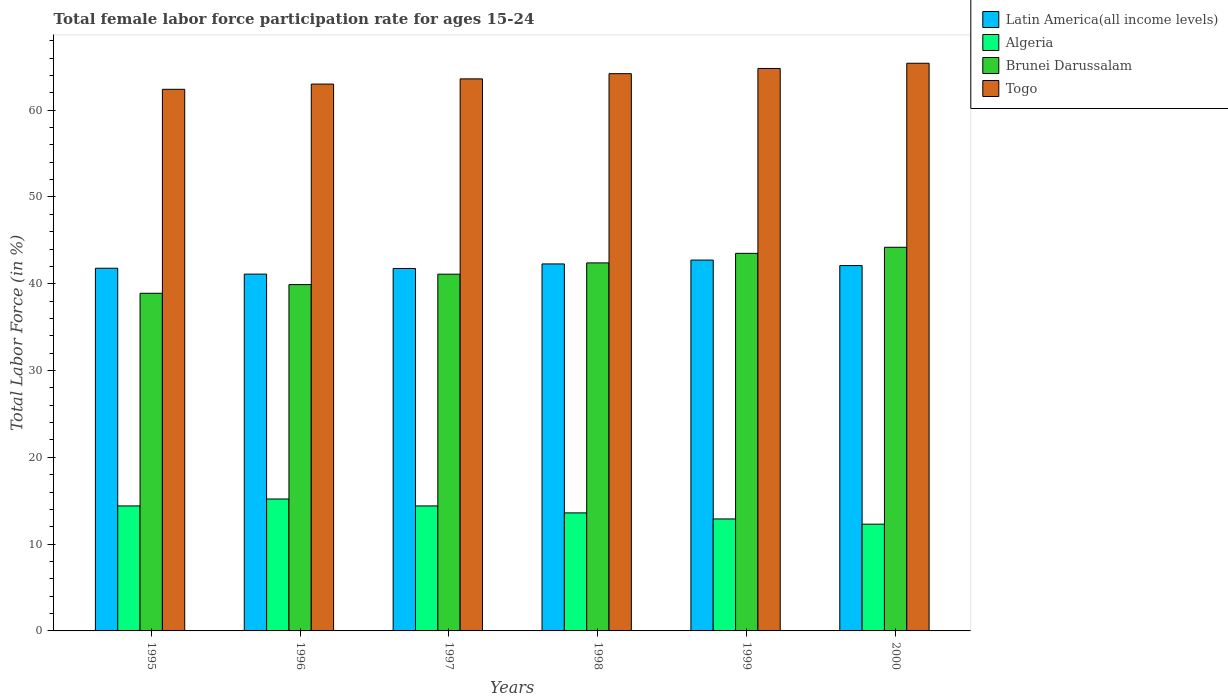How many different coloured bars are there?
Your answer should be very brief. 4. How many bars are there on the 4th tick from the right?
Your answer should be compact. 4. What is the label of the 3rd group of bars from the left?
Offer a terse response. 1997. What is the female labor force participation rate in Latin America(all income levels) in 1998?
Offer a very short reply. 42.28. Across all years, what is the maximum female labor force participation rate in Latin America(all income levels)?
Your answer should be compact. 42.72. Across all years, what is the minimum female labor force participation rate in Togo?
Your answer should be compact. 62.4. What is the total female labor force participation rate in Togo in the graph?
Your answer should be compact. 383.4. What is the difference between the female labor force participation rate in Brunei Darussalam in 1997 and that in 2000?
Ensure brevity in your answer.  -3.1. What is the difference between the female labor force participation rate in Latin America(all income levels) in 1998 and the female labor force participation rate in Brunei Darussalam in 1996?
Give a very brief answer. 2.38. What is the average female labor force participation rate in Algeria per year?
Offer a very short reply. 13.8. In the year 1999, what is the difference between the female labor force participation rate in Latin America(all income levels) and female labor force participation rate in Brunei Darussalam?
Your answer should be very brief. -0.78. In how many years, is the female labor force participation rate in Latin America(all income levels) greater than 10 %?
Your response must be concise. 6. What is the ratio of the female labor force participation rate in Latin America(all income levels) in 1996 to that in 1999?
Keep it short and to the point. 0.96. Is the female labor force participation rate in Algeria in 1996 less than that in 1997?
Provide a succinct answer. No. Is the difference between the female labor force participation rate in Latin America(all income levels) in 1999 and 2000 greater than the difference between the female labor force participation rate in Brunei Darussalam in 1999 and 2000?
Provide a short and direct response. Yes. What is the difference between the highest and the second highest female labor force participation rate in Algeria?
Provide a short and direct response. 0.8. What is the difference between the highest and the lowest female labor force participation rate in Togo?
Keep it short and to the point. 3. What does the 1st bar from the left in 1997 represents?
Keep it short and to the point. Latin America(all income levels). What does the 2nd bar from the right in 1997 represents?
Offer a very short reply. Brunei Darussalam. Is it the case that in every year, the sum of the female labor force participation rate in Algeria and female labor force participation rate in Brunei Darussalam is greater than the female labor force participation rate in Latin America(all income levels)?
Provide a succinct answer. Yes. How many bars are there?
Provide a succinct answer. 24. Are all the bars in the graph horizontal?
Your response must be concise. No. How many years are there in the graph?
Provide a short and direct response. 6. What is the difference between two consecutive major ticks on the Y-axis?
Ensure brevity in your answer.  10. How many legend labels are there?
Provide a succinct answer. 4. What is the title of the graph?
Your response must be concise. Total female labor force participation rate for ages 15-24. What is the label or title of the Y-axis?
Provide a short and direct response. Total Labor Force (in %). What is the Total Labor Force (in %) of Latin America(all income levels) in 1995?
Offer a very short reply. 41.78. What is the Total Labor Force (in %) of Algeria in 1995?
Your answer should be compact. 14.4. What is the Total Labor Force (in %) in Brunei Darussalam in 1995?
Your answer should be compact. 38.9. What is the Total Labor Force (in %) in Togo in 1995?
Your answer should be very brief. 62.4. What is the Total Labor Force (in %) of Latin America(all income levels) in 1996?
Keep it short and to the point. 41.11. What is the Total Labor Force (in %) in Algeria in 1996?
Offer a very short reply. 15.2. What is the Total Labor Force (in %) of Brunei Darussalam in 1996?
Offer a very short reply. 39.9. What is the Total Labor Force (in %) of Latin America(all income levels) in 1997?
Your response must be concise. 41.76. What is the Total Labor Force (in %) of Algeria in 1997?
Ensure brevity in your answer.  14.4. What is the Total Labor Force (in %) of Brunei Darussalam in 1997?
Your answer should be compact. 41.1. What is the Total Labor Force (in %) in Togo in 1997?
Keep it short and to the point. 63.6. What is the Total Labor Force (in %) of Latin America(all income levels) in 1998?
Provide a short and direct response. 42.28. What is the Total Labor Force (in %) in Algeria in 1998?
Offer a very short reply. 13.6. What is the Total Labor Force (in %) of Brunei Darussalam in 1998?
Your response must be concise. 42.4. What is the Total Labor Force (in %) of Togo in 1998?
Ensure brevity in your answer.  64.2. What is the Total Labor Force (in %) in Latin America(all income levels) in 1999?
Give a very brief answer. 42.72. What is the Total Labor Force (in %) of Algeria in 1999?
Ensure brevity in your answer.  12.9. What is the Total Labor Force (in %) of Brunei Darussalam in 1999?
Offer a terse response. 43.5. What is the Total Labor Force (in %) in Togo in 1999?
Give a very brief answer. 64.8. What is the Total Labor Force (in %) of Latin America(all income levels) in 2000?
Your answer should be very brief. 42.09. What is the Total Labor Force (in %) in Algeria in 2000?
Your response must be concise. 12.3. What is the Total Labor Force (in %) in Brunei Darussalam in 2000?
Your answer should be very brief. 44.2. What is the Total Labor Force (in %) in Togo in 2000?
Your answer should be very brief. 65.4. Across all years, what is the maximum Total Labor Force (in %) in Latin America(all income levels)?
Give a very brief answer. 42.72. Across all years, what is the maximum Total Labor Force (in %) of Algeria?
Offer a very short reply. 15.2. Across all years, what is the maximum Total Labor Force (in %) of Brunei Darussalam?
Offer a very short reply. 44.2. Across all years, what is the maximum Total Labor Force (in %) of Togo?
Your answer should be compact. 65.4. Across all years, what is the minimum Total Labor Force (in %) in Latin America(all income levels)?
Keep it short and to the point. 41.11. Across all years, what is the minimum Total Labor Force (in %) in Algeria?
Offer a very short reply. 12.3. Across all years, what is the minimum Total Labor Force (in %) of Brunei Darussalam?
Provide a succinct answer. 38.9. Across all years, what is the minimum Total Labor Force (in %) of Togo?
Provide a short and direct response. 62.4. What is the total Total Labor Force (in %) in Latin America(all income levels) in the graph?
Offer a very short reply. 251.74. What is the total Total Labor Force (in %) in Algeria in the graph?
Ensure brevity in your answer.  82.8. What is the total Total Labor Force (in %) in Brunei Darussalam in the graph?
Make the answer very short. 250. What is the total Total Labor Force (in %) of Togo in the graph?
Keep it short and to the point. 383.4. What is the difference between the Total Labor Force (in %) in Latin America(all income levels) in 1995 and that in 1996?
Offer a very short reply. 0.68. What is the difference between the Total Labor Force (in %) in Brunei Darussalam in 1995 and that in 1996?
Provide a short and direct response. -1. What is the difference between the Total Labor Force (in %) in Togo in 1995 and that in 1996?
Provide a succinct answer. -0.6. What is the difference between the Total Labor Force (in %) in Latin America(all income levels) in 1995 and that in 1997?
Make the answer very short. 0.03. What is the difference between the Total Labor Force (in %) of Brunei Darussalam in 1995 and that in 1997?
Provide a short and direct response. -2.2. What is the difference between the Total Labor Force (in %) in Togo in 1995 and that in 1997?
Offer a terse response. -1.2. What is the difference between the Total Labor Force (in %) of Latin America(all income levels) in 1995 and that in 1998?
Make the answer very short. -0.5. What is the difference between the Total Labor Force (in %) of Algeria in 1995 and that in 1998?
Your answer should be very brief. 0.8. What is the difference between the Total Labor Force (in %) of Togo in 1995 and that in 1998?
Offer a very short reply. -1.8. What is the difference between the Total Labor Force (in %) in Latin America(all income levels) in 1995 and that in 1999?
Keep it short and to the point. -0.94. What is the difference between the Total Labor Force (in %) in Algeria in 1995 and that in 1999?
Offer a very short reply. 1.5. What is the difference between the Total Labor Force (in %) in Latin America(all income levels) in 1995 and that in 2000?
Offer a terse response. -0.31. What is the difference between the Total Labor Force (in %) in Latin America(all income levels) in 1996 and that in 1997?
Offer a terse response. -0.65. What is the difference between the Total Labor Force (in %) in Latin America(all income levels) in 1996 and that in 1998?
Keep it short and to the point. -1.17. What is the difference between the Total Labor Force (in %) of Brunei Darussalam in 1996 and that in 1998?
Your answer should be compact. -2.5. What is the difference between the Total Labor Force (in %) in Latin America(all income levels) in 1996 and that in 1999?
Your answer should be compact. -1.62. What is the difference between the Total Labor Force (in %) in Brunei Darussalam in 1996 and that in 1999?
Provide a short and direct response. -3.6. What is the difference between the Total Labor Force (in %) in Latin America(all income levels) in 1996 and that in 2000?
Keep it short and to the point. -0.98. What is the difference between the Total Labor Force (in %) in Brunei Darussalam in 1996 and that in 2000?
Keep it short and to the point. -4.3. What is the difference between the Total Labor Force (in %) of Togo in 1996 and that in 2000?
Keep it short and to the point. -2.4. What is the difference between the Total Labor Force (in %) of Latin America(all income levels) in 1997 and that in 1998?
Ensure brevity in your answer.  -0.52. What is the difference between the Total Labor Force (in %) in Latin America(all income levels) in 1997 and that in 1999?
Your answer should be very brief. -0.97. What is the difference between the Total Labor Force (in %) of Algeria in 1997 and that in 1999?
Make the answer very short. 1.5. What is the difference between the Total Labor Force (in %) in Brunei Darussalam in 1997 and that in 1999?
Your answer should be compact. -2.4. What is the difference between the Total Labor Force (in %) of Togo in 1997 and that in 1999?
Provide a succinct answer. -1.2. What is the difference between the Total Labor Force (in %) of Latin America(all income levels) in 1997 and that in 2000?
Provide a succinct answer. -0.33. What is the difference between the Total Labor Force (in %) of Algeria in 1997 and that in 2000?
Give a very brief answer. 2.1. What is the difference between the Total Labor Force (in %) of Brunei Darussalam in 1997 and that in 2000?
Give a very brief answer. -3.1. What is the difference between the Total Labor Force (in %) of Togo in 1997 and that in 2000?
Your answer should be compact. -1.8. What is the difference between the Total Labor Force (in %) in Latin America(all income levels) in 1998 and that in 1999?
Keep it short and to the point. -0.44. What is the difference between the Total Labor Force (in %) in Algeria in 1998 and that in 1999?
Your response must be concise. 0.7. What is the difference between the Total Labor Force (in %) of Brunei Darussalam in 1998 and that in 1999?
Provide a short and direct response. -1.1. What is the difference between the Total Labor Force (in %) of Latin America(all income levels) in 1998 and that in 2000?
Your answer should be very brief. 0.19. What is the difference between the Total Labor Force (in %) of Algeria in 1998 and that in 2000?
Ensure brevity in your answer.  1.3. What is the difference between the Total Labor Force (in %) in Latin America(all income levels) in 1999 and that in 2000?
Offer a very short reply. 0.63. What is the difference between the Total Labor Force (in %) of Brunei Darussalam in 1999 and that in 2000?
Offer a very short reply. -0.7. What is the difference between the Total Labor Force (in %) in Latin America(all income levels) in 1995 and the Total Labor Force (in %) in Algeria in 1996?
Keep it short and to the point. 26.58. What is the difference between the Total Labor Force (in %) in Latin America(all income levels) in 1995 and the Total Labor Force (in %) in Brunei Darussalam in 1996?
Offer a terse response. 1.88. What is the difference between the Total Labor Force (in %) of Latin America(all income levels) in 1995 and the Total Labor Force (in %) of Togo in 1996?
Provide a succinct answer. -21.22. What is the difference between the Total Labor Force (in %) in Algeria in 1995 and the Total Labor Force (in %) in Brunei Darussalam in 1996?
Provide a short and direct response. -25.5. What is the difference between the Total Labor Force (in %) of Algeria in 1995 and the Total Labor Force (in %) of Togo in 1996?
Your answer should be compact. -48.6. What is the difference between the Total Labor Force (in %) of Brunei Darussalam in 1995 and the Total Labor Force (in %) of Togo in 1996?
Give a very brief answer. -24.1. What is the difference between the Total Labor Force (in %) in Latin America(all income levels) in 1995 and the Total Labor Force (in %) in Algeria in 1997?
Your response must be concise. 27.38. What is the difference between the Total Labor Force (in %) of Latin America(all income levels) in 1995 and the Total Labor Force (in %) of Brunei Darussalam in 1997?
Offer a very short reply. 0.68. What is the difference between the Total Labor Force (in %) of Latin America(all income levels) in 1995 and the Total Labor Force (in %) of Togo in 1997?
Give a very brief answer. -21.82. What is the difference between the Total Labor Force (in %) of Algeria in 1995 and the Total Labor Force (in %) of Brunei Darussalam in 1997?
Make the answer very short. -26.7. What is the difference between the Total Labor Force (in %) of Algeria in 1995 and the Total Labor Force (in %) of Togo in 1997?
Offer a terse response. -49.2. What is the difference between the Total Labor Force (in %) of Brunei Darussalam in 1995 and the Total Labor Force (in %) of Togo in 1997?
Offer a terse response. -24.7. What is the difference between the Total Labor Force (in %) of Latin America(all income levels) in 1995 and the Total Labor Force (in %) of Algeria in 1998?
Make the answer very short. 28.18. What is the difference between the Total Labor Force (in %) in Latin America(all income levels) in 1995 and the Total Labor Force (in %) in Brunei Darussalam in 1998?
Your answer should be very brief. -0.62. What is the difference between the Total Labor Force (in %) of Latin America(all income levels) in 1995 and the Total Labor Force (in %) of Togo in 1998?
Your response must be concise. -22.42. What is the difference between the Total Labor Force (in %) in Algeria in 1995 and the Total Labor Force (in %) in Brunei Darussalam in 1998?
Make the answer very short. -28. What is the difference between the Total Labor Force (in %) in Algeria in 1995 and the Total Labor Force (in %) in Togo in 1998?
Your response must be concise. -49.8. What is the difference between the Total Labor Force (in %) in Brunei Darussalam in 1995 and the Total Labor Force (in %) in Togo in 1998?
Provide a short and direct response. -25.3. What is the difference between the Total Labor Force (in %) of Latin America(all income levels) in 1995 and the Total Labor Force (in %) of Algeria in 1999?
Ensure brevity in your answer.  28.88. What is the difference between the Total Labor Force (in %) in Latin America(all income levels) in 1995 and the Total Labor Force (in %) in Brunei Darussalam in 1999?
Offer a terse response. -1.72. What is the difference between the Total Labor Force (in %) of Latin America(all income levels) in 1995 and the Total Labor Force (in %) of Togo in 1999?
Your answer should be compact. -23.02. What is the difference between the Total Labor Force (in %) of Algeria in 1995 and the Total Labor Force (in %) of Brunei Darussalam in 1999?
Keep it short and to the point. -29.1. What is the difference between the Total Labor Force (in %) of Algeria in 1995 and the Total Labor Force (in %) of Togo in 1999?
Make the answer very short. -50.4. What is the difference between the Total Labor Force (in %) in Brunei Darussalam in 1995 and the Total Labor Force (in %) in Togo in 1999?
Give a very brief answer. -25.9. What is the difference between the Total Labor Force (in %) in Latin America(all income levels) in 1995 and the Total Labor Force (in %) in Algeria in 2000?
Your answer should be very brief. 29.48. What is the difference between the Total Labor Force (in %) of Latin America(all income levels) in 1995 and the Total Labor Force (in %) of Brunei Darussalam in 2000?
Offer a terse response. -2.42. What is the difference between the Total Labor Force (in %) in Latin America(all income levels) in 1995 and the Total Labor Force (in %) in Togo in 2000?
Your response must be concise. -23.62. What is the difference between the Total Labor Force (in %) of Algeria in 1995 and the Total Labor Force (in %) of Brunei Darussalam in 2000?
Your answer should be compact. -29.8. What is the difference between the Total Labor Force (in %) in Algeria in 1995 and the Total Labor Force (in %) in Togo in 2000?
Offer a terse response. -51. What is the difference between the Total Labor Force (in %) of Brunei Darussalam in 1995 and the Total Labor Force (in %) of Togo in 2000?
Your answer should be very brief. -26.5. What is the difference between the Total Labor Force (in %) of Latin America(all income levels) in 1996 and the Total Labor Force (in %) of Algeria in 1997?
Your response must be concise. 26.71. What is the difference between the Total Labor Force (in %) in Latin America(all income levels) in 1996 and the Total Labor Force (in %) in Brunei Darussalam in 1997?
Make the answer very short. 0.01. What is the difference between the Total Labor Force (in %) in Latin America(all income levels) in 1996 and the Total Labor Force (in %) in Togo in 1997?
Offer a very short reply. -22.49. What is the difference between the Total Labor Force (in %) of Algeria in 1996 and the Total Labor Force (in %) of Brunei Darussalam in 1997?
Your answer should be compact. -25.9. What is the difference between the Total Labor Force (in %) in Algeria in 1996 and the Total Labor Force (in %) in Togo in 1997?
Give a very brief answer. -48.4. What is the difference between the Total Labor Force (in %) of Brunei Darussalam in 1996 and the Total Labor Force (in %) of Togo in 1997?
Offer a terse response. -23.7. What is the difference between the Total Labor Force (in %) of Latin America(all income levels) in 1996 and the Total Labor Force (in %) of Algeria in 1998?
Make the answer very short. 27.51. What is the difference between the Total Labor Force (in %) of Latin America(all income levels) in 1996 and the Total Labor Force (in %) of Brunei Darussalam in 1998?
Your answer should be very brief. -1.29. What is the difference between the Total Labor Force (in %) in Latin America(all income levels) in 1996 and the Total Labor Force (in %) in Togo in 1998?
Your answer should be compact. -23.09. What is the difference between the Total Labor Force (in %) of Algeria in 1996 and the Total Labor Force (in %) of Brunei Darussalam in 1998?
Provide a short and direct response. -27.2. What is the difference between the Total Labor Force (in %) of Algeria in 1996 and the Total Labor Force (in %) of Togo in 1998?
Your answer should be compact. -49. What is the difference between the Total Labor Force (in %) of Brunei Darussalam in 1996 and the Total Labor Force (in %) of Togo in 1998?
Give a very brief answer. -24.3. What is the difference between the Total Labor Force (in %) of Latin America(all income levels) in 1996 and the Total Labor Force (in %) of Algeria in 1999?
Your answer should be compact. 28.21. What is the difference between the Total Labor Force (in %) of Latin America(all income levels) in 1996 and the Total Labor Force (in %) of Brunei Darussalam in 1999?
Ensure brevity in your answer.  -2.39. What is the difference between the Total Labor Force (in %) of Latin America(all income levels) in 1996 and the Total Labor Force (in %) of Togo in 1999?
Provide a short and direct response. -23.69. What is the difference between the Total Labor Force (in %) of Algeria in 1996 and the Total Labor Force (in %) of Brunei Darussalam in 1999?
Your answer should be very brief. -28.3. What is the difference between the Total Labor Force (in %) in Algeria in 1996 and the Total Labor Force (in %) in Togo in 1999?
Provide a succinct answer. -49.6. What is the difference between the Total Labor Force (in %) in Brunei Darussalam in 1996 and the Total Labor Force (in %) in Togo in 1999?
Give a very brief answer. -24.9. What is the difference between the Total Labor Force (in %) in Latin America(all income levels) in 1996 and the Total Labor Force (in %) in Algeria in 2000?
Make the answer very short. 28.81. What is the difference between the Total Labor Force (in %) in Latin America(all income levels) in 1996 and the Total Labor Force (in %) in Brunei Darussalam in 2000?
Your answer should be very brief. -3.09. What is the difference between the Total Labor Force (in %) of Latin America(all income levels) in 1996 and the Total Labor Force (in %) of Togo in 2000?
Provide a succinct answer. -24.29. What is the difference between the Total Labor Force (in %) of Algeria in 1996 and the Total Labor Force (in %) of Brunei Darussalam in 2000?
Ensure brevity in your answer.  -29. What is the difference between the Total Labor Force (in %) in Algeria in 1996 and the Total Labor Force (in %) in Togo in 2000?
Your answer should be compact. -50.2. What is the difference between the Total Labor Force (in %) in Brunei Darussalam in 1996 and the Total Labor Force (in %) in Togo in 2000?
Your response must be concise. -25.5. What is the difference between the Total Labor Force (in %) in Latin America(all income levels) in 1997 and the Total Labor Force (in %) in Algeria in 1998?
Provide a short and direct response. 28.16. What is the difference between the Total Labor Force (in %) of Latin America(all income levels) in 1997 and the Total Labor Force (in %) of Brunei Darussalam in 1998?
Provide a succinct answer. -0.64. What is the difference between the Total Labor Force (in %) in Latin America(all income levels) in 1997 and the Total Labor Force (in %) in Togo in 1998?
Give a very brief answer. -22.44. What is the difference between the Total Labor Force (in %) in Algeria in 1997 and the Total Labor Force (in %) in Togo in 1998?
Offer a very short reply. -49.8. What is the difference between the Total Labor Force (in %) in Brunei Darussalam in 1997 and the Total Labor Force (in %) in Togo in 1998?
Your answer should be very brief. -23.1. What is the difference between the Total Labor Force (in %) in Latin America(all income levels) in 1997 and the Total Labor Force (in %) in Algeria in 1999?
Ensure brevity in your answer.  28.86. What is the difference between the Total Labor Force (in %) in Latin America(all income levels) in 1997 and the Total Labor Force (in %) in Brunei Darussalam in 1999?
Provide a short and direct response. -1.74. What is the difference between the Total Labor Force (in %) of Latin America(all income levels) in 1997 and the Total Labor Force (in %) of Togo in 1999?
Your answer should be compact. -23.04. What is the difference between the Total Labor Force (in %) in Algeria in 1997 and the Total Labor Force (in %) in Brunei Darussalam in 1999?
Your answer should be compact. -29.1. What is the difference between the Total Labor Force (in %) in Algeria in 1997 and the Total Labor Force (in %) in Togo in 1999?
Keep it short and to the point. -50.4. What is the difference between the Total Labor Force (in %) of Brunei Darussalam in 1997 and the Total Labor Force (in %) of Togo in 1999?
Make the answer very short. -23.7. What is the difference between the Total Labor Force (in %) of Latin America(all income levels) in 1997 and the Total Labor Force (in %) of Algeria in 2000?
Ensure brevity in your answer.  29.46. What is the difference between the Total Labor Force (in %) in Latin America(all income levels) in 1997 and the Total Labor Force (in %) in Brunei Darussalam in 2000?
Your response must be concise. -2.44. What is the difference between the Total Labor Force (in %) of Latin America(all income levels) in 1997 and the Total Labor Force (in %) of Togo in 2000?
Offer a very short reply. -23.64. What is the difference between the Total Labor Force (in %) of Algeria in 1997 and the Total Labor Force (in %) of Brunei Darussalam in 2000?
Your response must be concise. -29.8. What is the difference between the Total Labor Force (in %) in Algeria in 1997 and the Total Labor Force (in %) in Togo in 2000?
Your answer should be very brief. -51. What is the difference between the Total Labor Force (in %) of Brunei Darussalam in 1997 and the Total Labor Force (in %) of Togo in 2000?
Provide a succinct answer. -24.3. What is the difference between the Total Labor Force (in %) in Latin America(all income levels) in 1998 and the Total Labor Force (in %) in Algeria in 1999?
Provide a short and direct response. 29.38. What is the difference between the Total Labor Force (in %) in Latin America(all income levels) in 1998 and the Total Labor Force (in %) in Brunei Darussalam in 1999?
Make the answer very short. -1.22. What is the difference between the Total Labor Force (in %) of Latin America(all income levels) in 1998 and the Total Labor Force (in %) of Togo in 1999?
Provide a short and direct response. -22.52. What is the difference between the Total Labor Force (in %) of Algeria in 1998 and the Total Labor Force (in %) of Brunei Darussalam in 1999?
Your answer should be compact. -29.9. What is the difference between the Total Labor Force (in %) of Algeria in 1998 and the Total Labor Force (in %) of Togo in 1999?
Make the answer very short. -51.2. What is the difference between the Total Labor Force (in %) in Brunei Darussalam in 1998 and the Total Labor Force (in %) in Togo in 1999?
Provide a succinct answer. -22.4. What is the difference between the Total Labor Force (in %) of Latin America(all income levels) in 1998 and the Total Labor Force (in %) of Algeria in 2000?
Provide a succinct answer. 29.98. What is the difference between the Total Labor Force (in %) of Latin America(all income levels) in 1998 and the Total Labor Force (in %) of Brunei Darussalam in 2000?
Keep it short and to the point. -1.92. What is the difference between the Total Labor Force (in %) of Latin America(all income levels) in 1998 and the Total Labor Force (in %) of Togo in 2000?
Provide a short and direct response. -23.12. What is the difference between the Total Labor Force (in %) of Algeria in 1998 and the Total Labor Force (in %) of Brunei Darussalam in 2000?
Keep it short and to the point. -30.6. What is the difference between the Total Labor Force (in %) of Algeria in 1998 and the Total Labor Force (in %) of Togo in 2000?
Offer a terse response. -51.8. What is the difference between the Total Labor Force (in %) of Latin America(all income levels) in 1999 and the Total Labor Force (in %) of Algeria in 2000?
Make the answer very short. 30.42. What is the difference between the Total Labor Force (in %) of Latin America(all income levels) in 1999 and the Total Labor Force (in %) of Brunei Darussalam in 2000?
Keep it short and to the point. -1.48. What is the difference between the Total Labor Force (in %) of Latin America(all income levels) in 1999 and the Total Labor Force (in %) of Togo in 2000?
Give a very brief answer. -22.68. What is the difference between the Total Labor Force (in %) in Algeria in 1999 and the Total Labor Force (in %) in Brunei Darussalam in 2000?
Keep it short and to the point. -31.3. What is the difference between the Total Labor Force (in %) of Algeria in 1999 and the Total Labor Force (in %) of Togo in 2000?
Provide a succinct answer. -52.5. What is the difference between the Total Labor Force (in %) of Brunei Darussalam in 1999 and the Total Labor Force (in %) of Togo in 2000?
Offer a terse response. -21.9. What is the average Total Labor Force (in %) of Latin America(all income levels) per year?
Keep it short and to the point. 41.96. What is the average Total Labor Force (in %) of Brunei Darussalam per year?
Ensure brevity in your answer.  41.67. What is the average Total Labor Force (in %) in Togo per year?
Keep it short and to the point. 63.9. In the year 1995, what is the difference between the Total Labor Force (in %) of Latin America(all income levels) and Total Labor Force (in %) of Algeria?
Offer a terse response. 27.38. In the year 1995, what is the difference between the Total Labor Force (in %) in Latin America(all income levels) and Total Labor Force (in %) in Brunei Darussalam?
Ensure brevity in your answer.  2.88. In the year 1995, what is the difference between the Total Labor Force (in %) of Latin America(all income levels) and Total Labor Force (in %) of Togo?
Your response must be concise. -20.62. In the year 1995, what is the difference between the Total Labor Force (in %) in Algeria and Total Labor Force (in %) in Brunei Darussalam?
Make the answer very short. -24.5. In the year 1995, what is the difference between the Total Labor Force (in %) of Algeria and Total Labor Force (in %) of Togo?
Ensure brevity in your answer.  -48. In the year 1995, what is the difference between the Total Labor Force (in %) of Brunei Darussalam and Total Labor Force (in %) of Togo?
Your answer should be very brief. -23.5. In the year 1996, what is the difference between the Total Labor Force (in %) in Latin America(all income levels) and Total Labor Force (in %) in Algeria?
Make the answer very short. 25.91. In the year 1996, what is the difference between the Total Labor Force (in %) of Latin America(all income levels) and Total Labor Force (in %) of Brunei Darussalam?
Your answer should be very brief. 1.21. In the year 1996, what is the difference between the Total Labor Force (in %) of Latin America(all income levels) and Total Labor Force (in %) of Togo?
Ensure brevity in your answer.  -21.89. In the year 1996, what is the difference between the Total Labor Force (in %) of Algeria and Total Labor Force (in %) of Brunei Darussalam?
Provide a short and direct response. -24.7. In the year 1996, what is the difference between the Total Labor Force (in %) in Algeria and Total Labor Force (in %) in Togo?
Your response must be concise. -47.8. In the year 1996, what is the difference between the Total Labor Force (in %) of Brunei Darussalam and Total Labor Force (in %) of Togo?
Give a very brief answer. -23.1. In the year 1997, what is the difference between the Total Labor Force (in %) of Latin America(all income levels) and Total Labor Force (in %) of Algeria?
Make the answer very short. 27.36. In the year 1997, what is the difference between the Total Labor Force (in %) in Latin America(all income levels) and Total Labor Force (in %) in Brunei Darussalam?
Ensure brevity in your answer.  0.66. In the year 1997, what is the difference between the Total Labor Force (in %) of Latin America(all income levels) and Total Labor Force (in %) of Togo?
Your response must be concise. -21.84. In the year 1997, what is the difference between the Total Labor Force (in %) of Algeria and Total Labor Force (in %) of Brunei Darussalam?
Your response must be concise. -26.7. In the year 1997, what is the difference between the Total Labor Force (in %) in Algeria and Total Labor Force (in %) in Togo?
Provide a succinct answer. -49.2. In the year 1997, what is the difference between the Total Labor Force (in %) in Brunei Darussalam and Total Labor Force (in %) in Togo?
Your answer should be compact. -22.5. In the year 1998, what is the difference between the Total Labor Force (in %) in Latin America(all income levels) and Total Labor Force (in %) in Algeria?
Offer a very short reply. 28.68. In the year 1998, what is the difference between the Total Labor Force (in %) of Latin America(all income levels) and Total Labor Force (in %) of Brunei Darussalam?
Your answer should be compact. -0.12. In the year 1998, what is the difference between the Total Labor Force (in %) in Latin America(all income levels) and Total Labor Force (in %) in Togo?
Offer a very short reply. -21.92. In the year 1998, what is the difference between the Total Labor Force (in %) in Algeria and Total Labor Force (in %) in Brunei Darussalam?
Keep it short and to the point. -28.8. In the year 1998, what is the difference between the Total Labor Force (in %) in Algeria and Total Labor Force (in %) in Togo?
Offer a very short reply. -50.6. In the year 1998, what is the difference between the Total Labor Force (in %) of Brunei Darussalam and Total Labor Force (in %) of Togo?
Provide a short and direct response. -21.8. In the year 1999, what is the difference between the Total Labor Force (in %) of Latin America(all income levels) and Total Labor Force (in %) of Algeria?
Provide a short and direct response. 29.82. In the year 1999, what is the difference between the Total Labor Force (in %) of Latin America(all income levels) and Total Labor Force (in %) of Brunei Darussalam?
Provide a succinct answer. -0.78. In the year 1999, what is the difference between the Total Labor Force (in %) in Latin America(all income levels) and Total Labor Force (in %) in Togo?
Your response must be concise. -22.08. In the year 1999, what is the difference between the Total Labor Force (in %) in Algeria and Total Labor Force (in %) in Brunei Darussalam?
Ensure brevity in your answer.  -30.6. In the year 1999, what is the difference between the Total Labor Force (in %) of Algeria and Total Labor Force (in %) of Togo?
Keep it short and to the point. -51.9. In the year 1999, what is the difference between the Total Labor Force (in %) in Brunei Darussalam and Total Labor Force (in %) in Togo?
Make the answer very short. -21.3. In the year 2000, what is the difference between the Total Labor Force (in %) in Latin America(all income levels) and Total Labor Force (in %) in Algeria?
Offer a very short reply. 29.79. In the year 2000, what is the difference between the Total Labor Force (in %) of Latin America(all income levels) and Total Labor Force (in %) of Brunei Darussalam?
Give a very brief answer. -2.11. In the year 2000, what is the difference between the Total Labor Force (in %) in Latin America(all income levels) and Total Labor Force (in %) in Togo?
Provide a succinct answer. -23.31. In the year 2000, what is the difference between the Total Labor Force (in %) of Algeria and Total Labor Force (in %) of Brunei Darussalam?
Keep it short and to the point. -31.9. In the year 2000, what is the difference between the Total Labor Force (in %) of Algeria and Total Labor Force (in %) of Togo?
Offer a terse response. -53.1. In the year 2000, what is the difference between the Total Labor Force (in %) of Brunei Darussalam and Total Labor Force (in %) of Togo?
Keep it short and to the point. -21.2. What is the ratio of the Total Labor Force (in %) in Latin America(all income levels) in 1995 to that in 1996?
Keep it short and to the point. 1.02. What is the ratio of the Total Labor Force (in %) in Algeria in 1995 to that in 1996?
Keep it short and to the point. 0.95. What is the ratio of the Total Labor Force (in %) of Brunei Darussalam in 1995 to that in 1996?
Your response must be concise. 0.97. What is the ratio of the Total Labor Force (in %) in Algeria in 1995 to that in 1997?
Ensure brevity in your answer.  1. What is the ratio of the Total Labor Force (in %) of Brunei Darussalam in 1995 to that in 1997?
Your response must be concise. 0.95. What is the ratio of the Total Labor Force (in %) in Togo in 1995 to that in 1997?
Offer a terse response. 0.98. What is the ratio of the Total Labor Force (in %) in Latin America(all income levels) in 1995 to that in 1998?
Offer a very short reply. 0.99. What is the ratio of the Total Labor Force (in %) in Algeria in 1995 to that in 1998?
Your response must be concise. 1.06. What is the ratio of the Total Labor Force (in %) in Brunei Darussalam in 1995 to that in 1998?
Offer a very short reply. 0.92. What is the ratio of the Total Labor Force (in %) in Latin America(all income levels) in 1995 to that in 1999?
Offer a very short reply. 0.98. What is the ratio of the Total Labor Force (in %) in Algeria in 1995 to that in 1999?
Make the answer very short. 1.12. What is the ratio of the Total Labor Force (in %) of Brunei Darussalam in 1995 to that in 1999?
Provide a succinct answer. 0.89. What is the ratio of the Total Labor Force (in %) of Togo in 1995 to that in 1999?
Offer a very short reply. 0.96. What is the ratio of the Total Labor Force (in %) in Latin America(all income levels) in 1995 to that in 2000?
Keep it short and to the point. 0.99. What is the ratio of the Total Labor Force (in %) in Algeria in 1995 to that in 2000?
Provide a short and direct response. 1.17. What is the ratio of the Total Labor Force (in %) of Brunei Darussalam in 1995 to that in 2000?
Keep it short and to the point. 0.88. What is the ratio of the Total Labor Force (in %) of Togo in 1995 to that in 2000?
Give a very brief answer. 0.95. What is the ratio of the Total Labor Force (in %) in Latin America(all income levels) in 1996 to that in 1997?
Offer a terse response. 0.98. What is the ratio of the Total Labor Force (in %) in Algeria in 1996 to that in 1997?
Your answer should be very brief. 1.06. What is the ratio of the Total Labor Force (in %) in Brunei Darussalam in 1996 to that in 1997?
Ensure brevity in your answer.  0.97. What is the ratio of the Total Labor Force (in %) in Togo in 1996 to that in 1997?
Your response must be concise. 0.99. What is the ratio of the Total Labor Force (in %) in Latin America(all income levels) in 1996 to that in 1998?
Provide a succinct answer. 0.97. What is the ratio of the Total Labor Force (in %) in Algeria in 1996 to that in 1998?
Offer a terse response. 1.12. What is the ratio of the Total Labor Force (in %) in Brunei Darussalam in 1996 to that in 1998?
Offer a very short reply. 0.94. What is the ratio of the Total Labor Force (in %) in Togo in 1996 to that in 1998?
Provide a short and direct response. 0.98. What is the ratio of the Total Labor Force (in %) in Latin America(all income levels) in 1996 to that in 1999?
Offer a terse response. 0.96. What is the ratio of the Total Labor Force (in %) in Algeria in 1996 to that in 1999?
Your response must be concise. 1.18. What is the ratio of the Total Labor Force (in %) in Brunei Darussalam in 1996 to that in 1999?
Your response must be concise. 0.92. What is the ratio of the Total Labor Force (in %) in Togo in 1996 to that in 1999?
Ensure brevity in your answer.  0.97. What is the ratio of the Total Labor Force (in %) in Latin America(all income levels) in 1996 to that in 2000?
Provide a succinct answer. 0.98. What is the ratio of the Total Labor Force (in %) of Algeria in 1996 to that in 2000?
Keep it short and to the point. 1.24. What is the ratio of the Total Labor Force (in %) in Brunei Darussalam in 1996 to that in 2000?
Offer a terse response. 0.9. What is the ratio of the Total Labor Force (in %) in Togo in 1996 to that in 2000?
Offer a terse response. 0.96. What is the ratio of the Total Labor Force (in %) in Latin America(all income levels) in 1997 to that in 1998?
Your answer should be very brief. 0.99. What is the ratio of the Total Labor Force (in %) of Algeria in 1997 to that in 1998?
Your response must be concise. 1.06. What is the ratio of the Total Labor Force (in %) of Brunei Darussalam in 1997 to that in 1998?
Ensure brevity in your answer.  0.97. What is the ratio of the Total Labor Force (in %) in Latin America(all income levels) in 1997 to that in 1999?
Your response must be concise. 0.98. What is the ratio of the Total Labor Force (in %) of Algeria in 1997 to that in 1999?
Provide a succinct answer. 1.12. What is the ratio of the Total Labor Force (in %) of Brunei Darussalam in 1997 to that in 1999?
Your response must be concise. 0.94. What is the ratio of the Total Labor Force (in %) of Togo in 1997 to that in 1999?
Your response must be concise. 0.98. What is the ratio of the Total Labor Force (in %) of Latin America(all income levels) in 1997 to that in 2000?
Ensure brevity in your answer.  0.99. What is the ratio of the Total Labor Force (in %) in Algeria in 1997 to that in 2000?
Your answer should be compact. 1.17. What is the ratio of the Total Labor Force (in %) in Brunei Darussalam in 1997 to that in 2000?
Provide a succinct answer. 0.93. What is the ratio of the Total Labor Force (in %) of Togo in 1997 to that in 2000?
Your answer should be compact. 0.97. What is the ratio of the Total Labor Force (in %) of Latin America(all income levels) in 1998 to that in 1999?
Your answer should be compact. 0.99. What is the ratio of the Total Labor Force (in %) of Algeria in 1998 to that in 1999?
Offer a terse response. 1.05. What is the ratio of the Total Labor Force (in %) in Brunei Darussalam in 1998 to that in 1999?
Keep it short and to the point. 0.97. What is the ratio of the Total Labor Force (in %) in Latin America(all income levels) in 1998 to that in 2000?
Your response must be concise. 1. What is the ratio of the Total Labor Force (in %) in Algeria in 1998 to that in 2000?
Provide a short and direct response. 1.11. What is the ratio of the Total Labor Force (in %) in Brunei Darussalam in 1998 to that in 2000?
Provide a short and direct response. 0.96. What is the ratio of the Total Labor Force (in %) in Togo in 1998 to that in 2000?
Give a very brief answer. 0.98. What is the ratio of the Total Labor Force (in %) of Algeria in 1999 to that in 2000?
Give a very brief answer. 1.05. What is the ratio of the Total Labor Force (in %) of Brunei Darussalam in 1999 to that in 2000?
Ensure brevity in your answer.  0.98. What is the difference between the highest and the second highest Total Labor Force (in %) of Latin America(all income levels)?
Offer a terse response. 0.44. What is the difference between the highest and the second highest Total Labor Force (in %) in Algeria?
Ensure brevity in your answer.  0.8. What is the difference between the highest and the lowest Total Labor Force (in %) in Latin America(all income levels)?
Make the answer very short. 1.62. What is the difference between the highest and the lowest Total Labor Force (in %) in Algeria?
Keep it short and to the point. 2.9. 